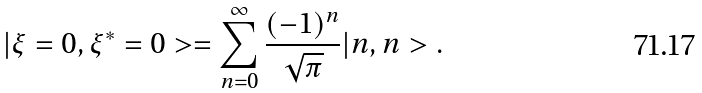<formula> <loc_0><loc_0><loc_500><loc_500>| \xi = 0 , \xi ^ { \ast } = 0 > = \sum _ { n = 0 } ^ { \infty } \frac { ( - 1 ) ^ { n } } { \sqrt { \pi } } | n , n > .</formula> 